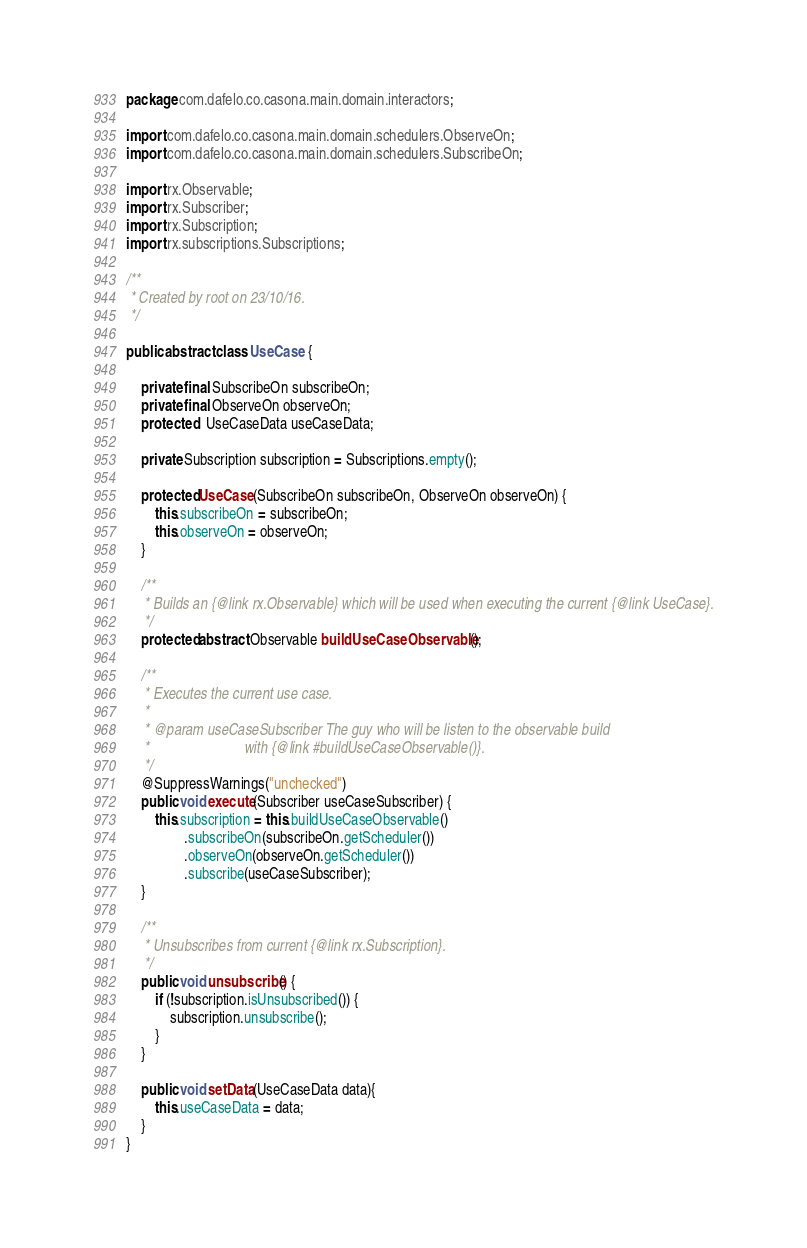Convert code to text. <code><loc_0><loc_0><loc_500><loc_500><_Java_>package com.dafelo.co.casona.main.domain.interactors;

import com.dafelo.co.casona.main.domain.schedulers.ObserveOn;
import com.dafelo.co.casona.main.domain.schedulers.SubscribeOn;

import rx.Observable;
import rx.Subscriber;
import rx.Subscription;
import rx.subscriptions.Subscriptions;

/**
 * Created by root on 23/10/16.
 */

public abstract class UseCase {

    private final SubscribeOn subscribeOn;
    private final ObserveOn observeOn;
    protected   UseCaseData useCaseData;

    private Subscription subscription = Subscriptions.empty();

    protected UseCase(SubscribeOn subscribeOn, ObserveOn observeOn) {
        this.subscribeOn = subscribeOn;
        this.observeOn = observeOn;
    }

    /**
     * Builds an {@link rx.Observable} which will be used when executing the current {@link UseCase}.
     */
    protected abstract Observable buildUseCaseObservable();

    /**
     * Executes the current use case.
     *
     * @param useCaseSubscriber The guy who will be listen to the observable build
     *                          with {@link #buildUseCaseObservable()}.
     */
    @SuppressWarnings("unchecked")
    public void execute(Subscriber useCaseSubscriber) {
        this.subscription = this.buildUseCaseObservable()
                .subscribeOn(subscribeOn.getScheduler())
                .observeOn(observeOn.getScheduler())
                .subscribe(useCaseSubscriber);
    }

    /**
     * Unsubscribes from current {@link rx.Subscription}.
     */
    public void unsubscribe() {
        if (!subscription.isUnsubscribed()) {
            subscription.unsubscribe();
        }
    }

    public void setData(UseCaseData data){
        this.useCaseData = data;
    }
}
</code> 